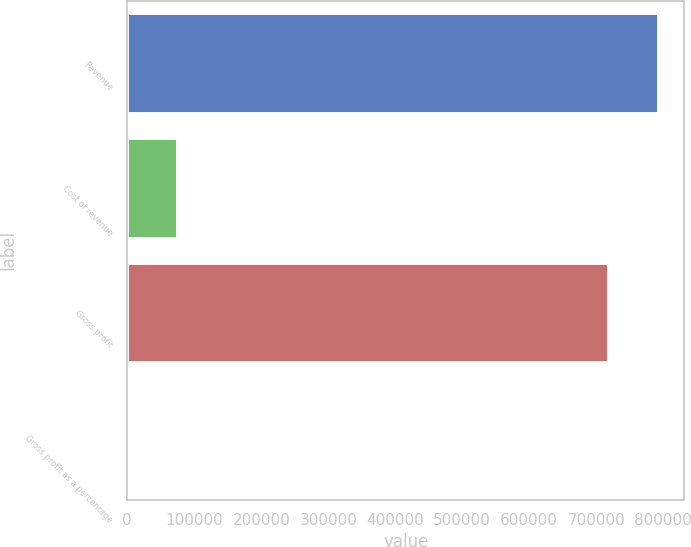<chart> <loc_0><loc_0><loc_500><loc_500><bar_chart><fcel>Revenue<fcel>Cost of revenue<fcel>Gross profit<fcel>Gross profit as a percentage<nl><fcel>791778<fcel>74103.1<fcel>717772<fcel>97<nl></chart> 